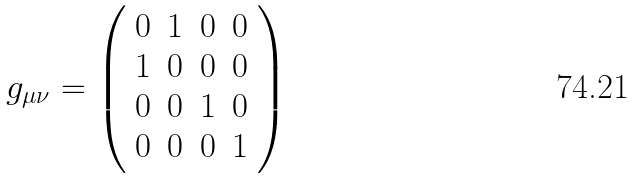<formula> <loc_0><loc_0><loc_500><loc_500>g _ { \mu \nu } = \left ( \begin{array} { c c c c } 0 & 1 & 0 & 0 \\ 1 & 0 & 0 & 0 \\ 0 & 0 & 1 & 0 \\ 0 & 0 & 0 & 1 \\ \end{array} \right )</formula> 